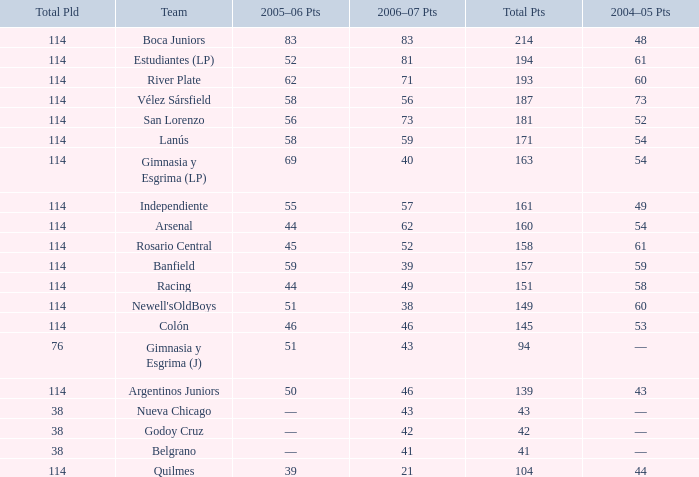What is the total number of points for a total pld less than 38? 0.0. 